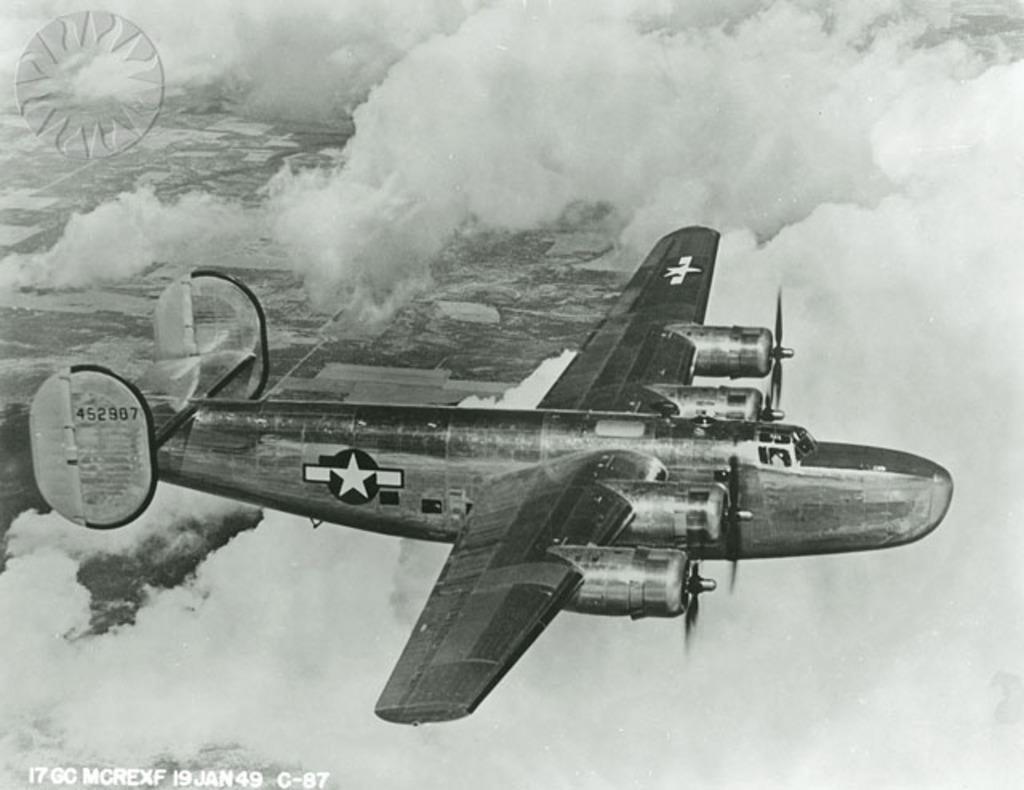<image>
Give a short and clear explanation of the subsequent image. A vintage picture shows an old fighter jet with 452907 written on its tail 